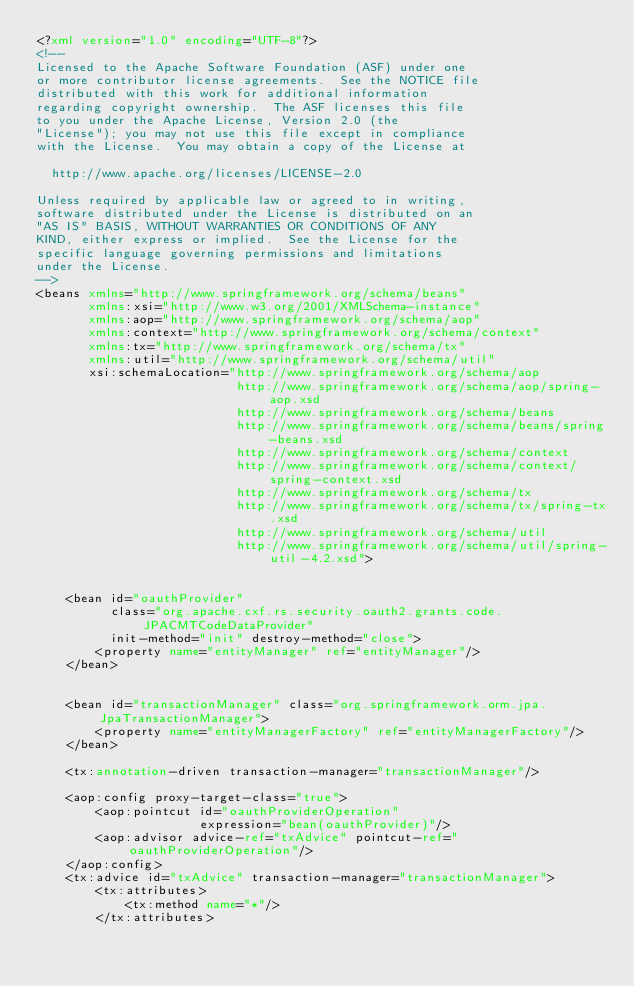Convert code to text. <code><loc_0><loc_0><loc_500><loc_500><_XML_><?xml version="1.0" encoding="UTF-8"?>
<!--
Licensed to the Apache Software Foundation (ASF) under one
or more contributor license agreements.  See the NOTICE file
distributed with this work for additional information
regarding copyright ownership.  The ASF licenses this file
to you under the Apache License, Version 2.0 (the
"License"); you may not use this file except in compliance
with the License.  You may obtain a copy of the License at

  http://www.apache.org/licenses/LICENSE-2.0

Unless required by applicable law or agreed to in writing,
software distributed under the License is distributed on an
"AS IS" BASIS, WITHOUT WARRANTIES OR CONDITIONS OF ANY
KIND, either express or implied.  See the License for the
specific language governing permissions and limitations
under the License.
-->
<beans xmlns="http://www.springframework.org/schema/beans"
       xmlns:xsi="http://www.w3.org/2001/XMLSchema-instance"
       xmlns:aop="http://www.springframework.org/schema/aop"
       xmlns:context="http://www.springframework.org/schema/context"
       xmlns:tx="http://www.springframework.org/schema/tx"
       xmlns:util="http://www.springframework.org/schema/util"
       xsi:schemaLocation="http://www.springframework.org/schema/aop
                           http://www.springframework.org/schema/aop/spring-aop.xsd
                           http://www.springframework.org/schema/beans
                           http://www.springframework.org/schema/beans/spring-beans.xsd
                           http://www.springframework.org/schema/context
                           http://www.springframework.org/schema/context/spring-context.xsd
                           http://www.springframework.org/schema/tx
                           http://www.springframework.org/schema/tx/spring-tx.xsd
                           http://www.springframework.org/schema/util
                           http://www.springframework.org/schema/util/spring-util-4.2.xsd">


    <bean id="oauthProvider"
          class="org.apache.cxf.rs.security.oauth2.grants.code.JPACMTCodeDataProvider"
          init-method="init" destroy-method="close">
        <property name="entityManager" ref="entityManager"/>
    </bean>


    <bean id="transactionManager" class="org.springframework.orm.jpa.JpaTransactionManager">
        <property name="entityManagerFactory" ref="entityManagerFactory"/>
    </bean>

    <tx:annotation-driven transaction-manager="transactionManager"/>

    <aop:config proxy-target-class="true">
        <aop:pointcut id="oauthProviderOperation"
                      expression="bean(oauthProvider)"/>
        <aop:advisor advice-ref="txAdvice" pointcut-ref="oauthProviderOperation"/>
    </aop:config>
    <tx:advice id="txAdvice" transaction-manager="transactionManager">
        <tx:attributes>
            <tx:method name="*"/>
        </tx:attributes></code> 